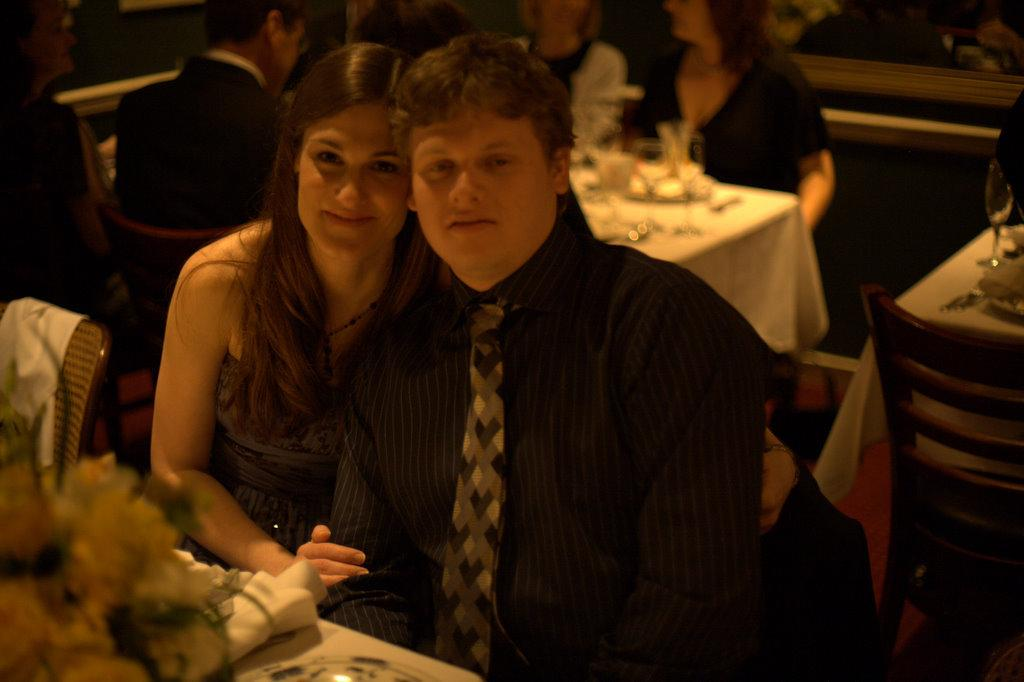How many people are present in the image? There are two people in the image. What are the two people doing? The two people are taking a photograph. Can you describe the interaction between the two people? A lady is holding the hand of a man. What can be seen in the background of the image? There is a group of people sitting on chairs in the background. What type of cave can be seen in the background of the image? There is no cave present in the image; it features two people taking a photograph and a group of people sitting on chairs in the background. 